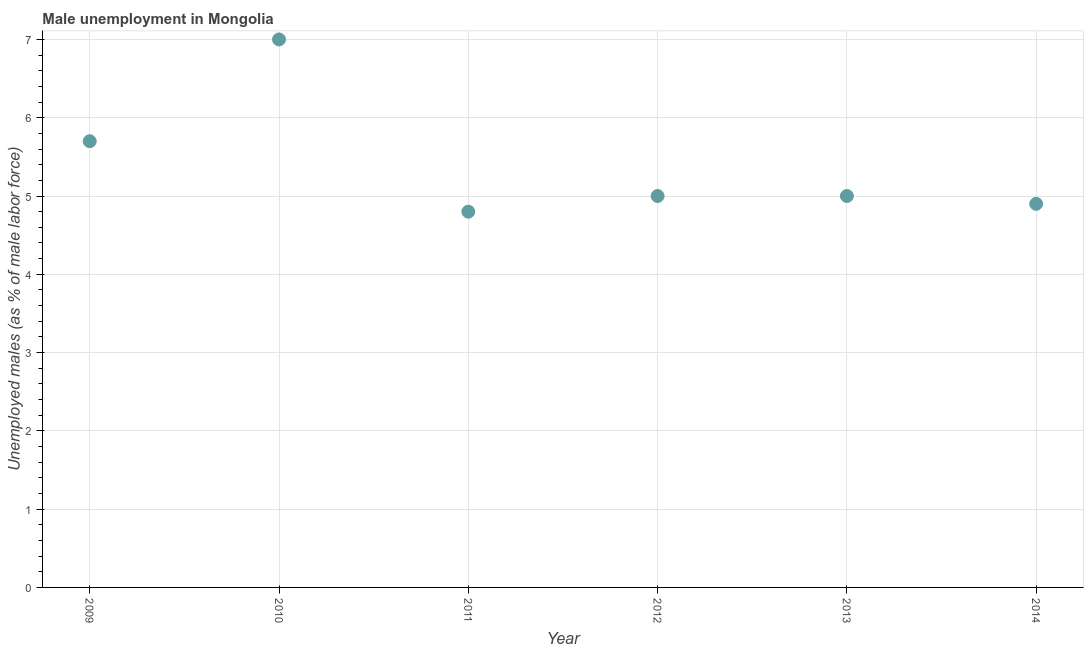What is the unemployed males population in 2014?
Your answer should be compact. 4.9. Across all years, what is the minimum unemployed males population?
Your response must be concise. 4.8. What is the sum of the unemployed males population?
Your answer should be very brief. 32.4. What is the difference between the unemployed males population in 2010 and 2014?
Your answer should be compact. 2.1. What is the average unemployed males population per year?
Your answer should be very brief. 5.4. In how many years, is the unemployed males population greater than 2.6 %?
Provide a short and direct response. 6. What is the ratio of the unemployed males population in 2009 to that in 2014?
Your answer should be very brief. 1.16. Is the unemployed males population in 2011 less than that in 2014?
Provide a succinct answer. Yes. What is the difference between the highest and the second highest unemployed males population?
Give a very brief answer. 1.3. What is the difference between the highest and the lowest unemployed males population?
Offer a very short reply. 2.2. In how many years, is the unemployed males population greater than the average unemployed males population taken over all years?
Ensure brevity in your answer.  2. Does the unemployed males population monotonically increase over the years?
Offer a very short reply. No. How many dotlines are there?
Offer a terse response. 1. How many years are there in the graph?
Provide a succinct answer. 6. Does the graph contain any zero values?
Provide a short and direct response. No. Does the graph contain grids?
Provide a short and direct response. Yes. What is the title of the graph?
Offer a terse response. Male unemployment in Mongolia. What is the label or title of the X-axis?
Provide a succinct answer. Year. What is the label or title of the Y-axis?
Provide a succinct answer. Unemployed males (as % of male labor force). What is the Unemployed males (as % of male labor force) in 2009?
Your answer should be very brief. 5.7. What is the Unemployed males (as % of male labor force) in 2011?
Ensure brevity in your answer.  4.8. What is the Unemployed males (as % of male labor force) in 2014?
Your answer should be compact. 4.9. What is the difference between the Unemployed males (as % of male labor force) in 2009 and 2010?
Make the answer very short. -1.3. What is the difference between the Unemployed males (as % of male labor force) in 2009 and 2011?
Offer a very short reply. 0.9. What is the difference between the Unemployed males (as % of male labor force) in 2009 and 2012?
Keep it short and to the point. 0.7. What is the difference between the Unemployed males (as % of male labor force) in 2010 and 2011?
Offer a terse response. 2.2. What is the difference between the Unemployed males (as % of male labor force) in 2010 and 2012?
Provide a short and direct response. 2. What is the difference between the Unemployed males (as % of male labor force) in 2010 and 2013?
Provide a succinct answer. 2. What is the difference between the Unemployed males (as % of male labor force) in 2010 and 2014?
Provide a succinct answer. 2.1. What is the difference between the Unemployed males (as % of male labor force) in 2011 and 2014?
Ensure brevity in your answer.  -0.1. What is the difference between the Unemployed males (as % of male labor force) in 2012 and 2013?
Make the answer very short. 0. What is the difference between the Unemployed males (as % of male labor force) in 2013 and 2014?
Ensure brevity in your answer.  0.1. What is the ratio of the Unemployed males (as % of male labor force) in 2009 to that in 2010?
Offer a very short reply. 0.81. What is the ratio of the Unemployed males (as % of male labor force) in 2009 to that in 2011?
Give a very brief answer. 1.19. What is the ratio of the Unemployed males (as % of male labor force) in 2009 to that in 2012?
Offer a terse response. 1.14. What is the ratio of the Unemployed males (as % of male labor force) in 2009 to that in 2013?
Make the answer very short. 1.14. What is the ratio of the Unemployed males (as % of male labor force) in 2009 to that in 2014?
Your answer should be very brief. 1.16. What is the ratio of the Unemployed males (as % of male labor force) in 2010 to that in 2011?
Your answer should be very brief. 1.46. What is the ratio of the Unemployed males (as % of male labor force) in 2010 to that in 2012?
Provide a short and direct response. 1.4. What is the ratio of the Unemployed males (as % of male labor force) in 2010 to that in 2013?
Your answer should be very brief. 1.4. What is the ratio of the Unemployed males (as % of male labor force) in 2010 to that in 2014?
Ensure brevity in your answer.  1.43. What is the ratio of the Unemployed males (as % of male labor force) in 2011 to that in 2012?
Provide a succinct answer. 0.96. What is the ratio of the Unemployed males (as % of male labor force) in 2011 to that in 2013?
Your answer should be very brief. 0.96. What is the ratio of the Unemployed males (as % of male labor force) in 2012 to that in 2013?
Ensure brevity in your answer.  1. 